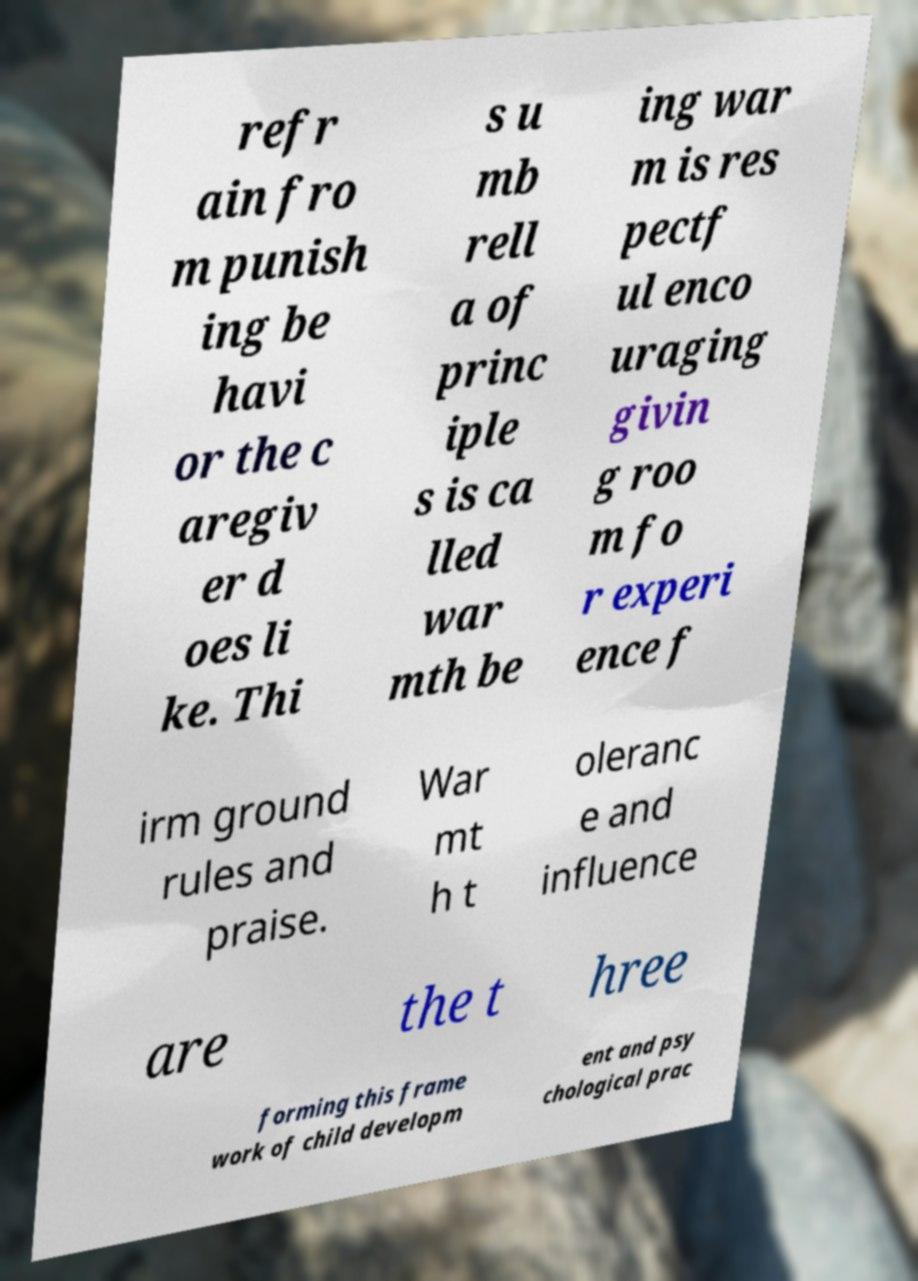Could you assist in decoding the text presented in this image and type it out clearly? refr ain fro m punish ing be havi or the c aregiv er d oes li ke. Thi s u mb rell a of princ iple s is ca lled war mth be ing war m is res pectf ul enco uraging givin g roo m fo r experi ence f irm ground rules and praise. War mt h t oleranc e and influence are the t hree forming this frame work of child developm ent and psy chological prac 